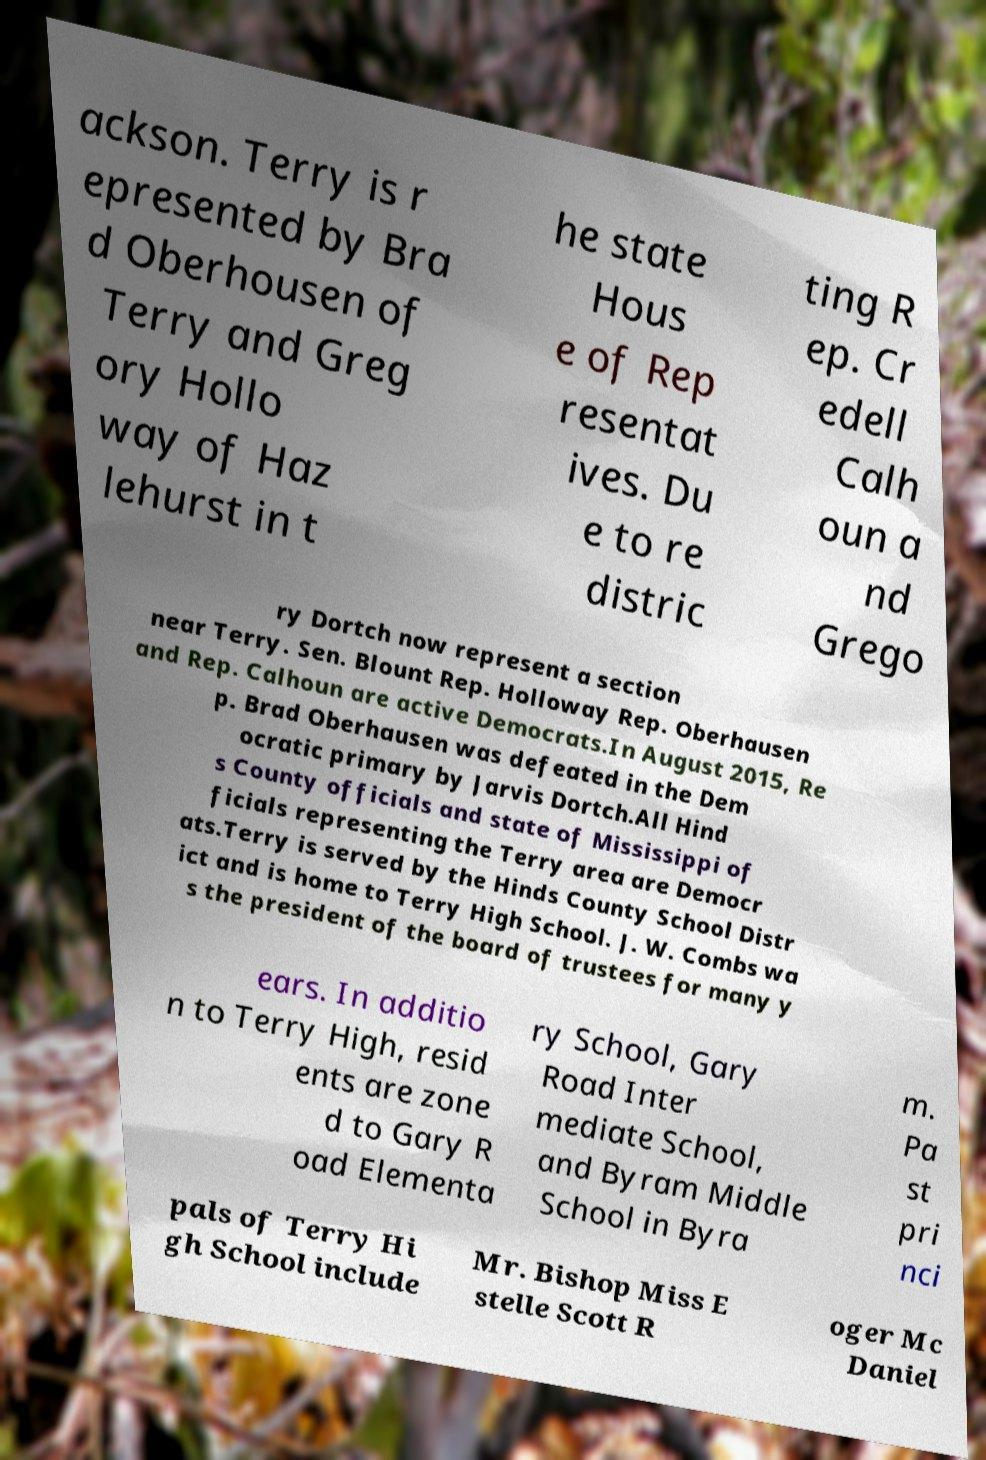Could you extract and type out the text from this image? ackson. Terry is r epresented by Bra d Oberhousen of Terry and Greg ory Hollo way of Haz lehurst in t he state Hous e of Rep resentat ives. Du e to re distric ting R ep. Cr edell Calh oun a nd Grego ry Dortch now represent a section near Terry. Sen. Blount Rep. Holloway Rep. Oberhausen and Rep. Calhoun are active Democrats.In August 2015, Re p. Brad Oberhausen was defeated in the Dem ocratic primary by Jarvis Dortch.All Hind s County officials and state of Mississippi of ficials representing the Terry area are Democr ats.Terry is served by the Hinds County School Distr ict and is home to Terry High School. J. W. Combs wa s the president of the board of trustees for many y ears. In additio n to Terry High, resid ents are zone d to Gary R oad Elementa ry School, Gary Road Inter mediate School, and Byram Middle School in Byra m. Pa st pri nci pals of Terry Hi gh School include Mr. Bishop Miss E stelle Scott R oger Mc Daniel 